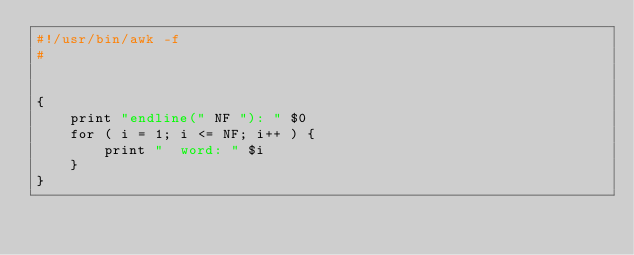Convert code to text. <code><loc_0><loc_0><loc_500><loc_500><_Awk_>#!/usr/bin/awk -f
#


{
	print "endline(" NF "): " $0
	for ( i = 1; i <= NF; i++ ) {
		print "  word: " $i
	}
}
</code> 